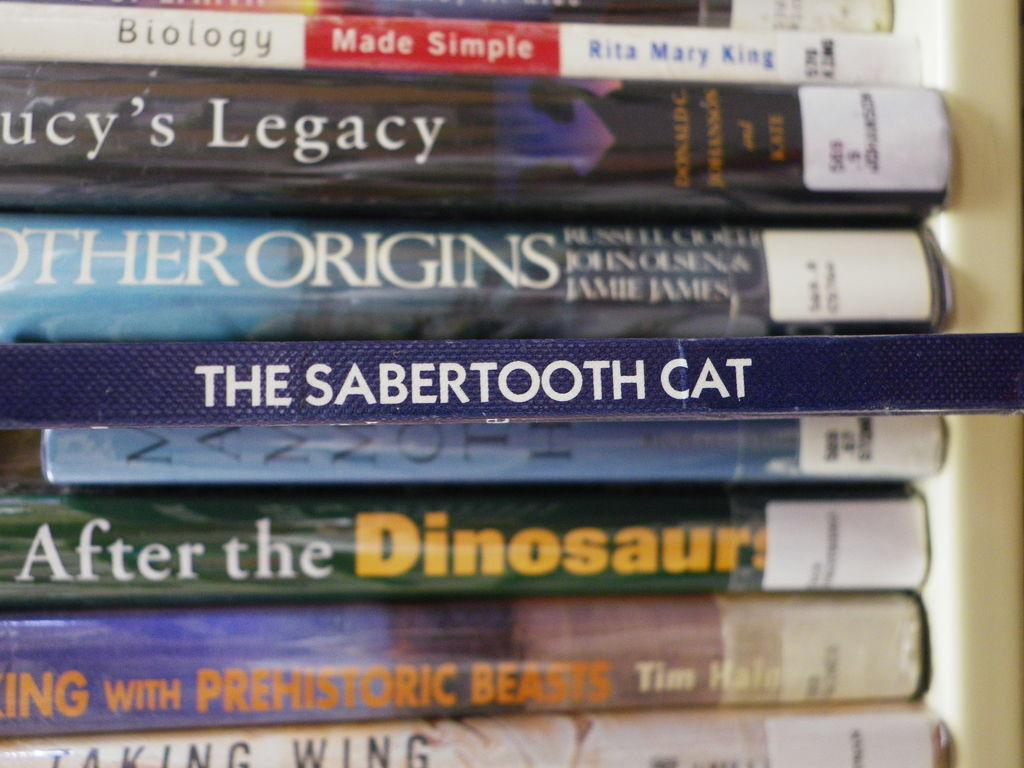<image>
Write a terse but informative summary of the picture. A stack of books with the middle book of The sabertooth cat. 